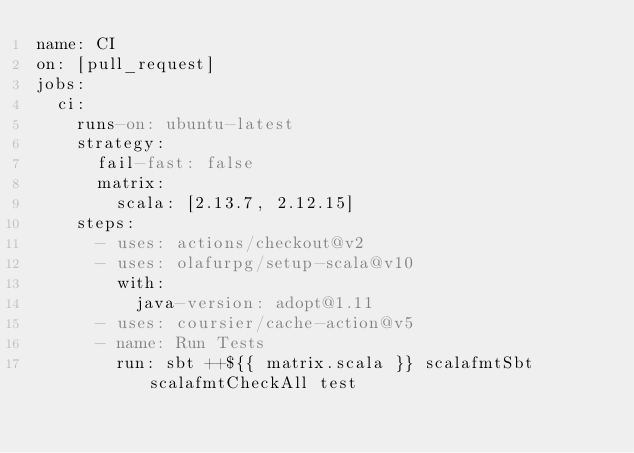Convert code to text. <code><loc_0><loc_0><loc_500><loc_500><_YAML_>name: CI
on: [pull_request]
jobs:
  ci:
    runs-on: ubuntu-latest
    strategy:
      fail-fast: false
      matrix:
        scala: [2.13.7, 2.12.15]
    steps:
      - uses: actions/checkout@v2
      - uses: olafurpg/setup-scala@v10
        with:
          java-version: adopt@1.11
      - uses: coursier/cache-action@v5
      - name: Run Tests
        run: sbt ++${{ matrix.scala }} scalafmtSbt scalafmtCheckAll test
</code> 